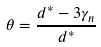<formula> <loc_0><loc_0><loc_500><loc_500>\theta = \frac { d ^ { * } - 3 \gamma _ { n } } { d ^ { * } }</formula> 